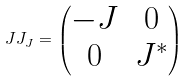Convert formula to latex. <formula><loc_0><loc_0><loc_500><loc_500>\ J J _ { J } = \left ( \begin{matrix} - J & 0 \\ 0 & J ^ { * } \end{matrix} \right )</formula> 